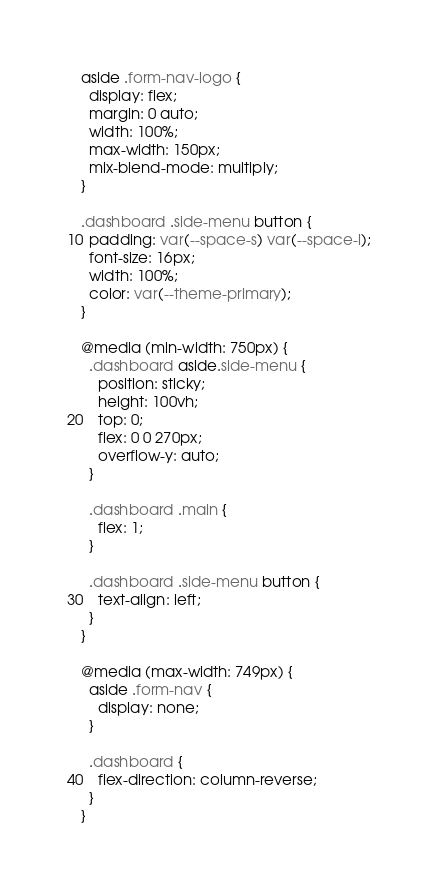Convert code to text. <code><loc_0><loc_0><loc_500><loc_500><_CSS_>aside .form-nav-logo {
  display: flex;
  margin: 0 auto;
  width: 100%;
  max-width: 150px;
  mix-blend-mode: multiply;
}

.dashboard .side-menu button {
  padding: var(--space-s) var(--space-l);
  font-size: 16px;
  width: 100%;
  color: var(--theme-primary);
}

@media (min-width: 750px) {
  .dashboard aside.side-menu {
    position: sticky;
    height: 100vh;
    top: 0;
    flex: 0 0 270px;
    overflow-y: auto;
  }

  .dashboard .main {
    flex: 1;
  }

  .dashboard .side-menu button {
    text-align: left;
  }
}

@media (max-width: 749px) {
  aside .form-nav {
    display: none;
  }

  .dashboard {
    flex-direction: column-reverse;
  }
}
</code> 